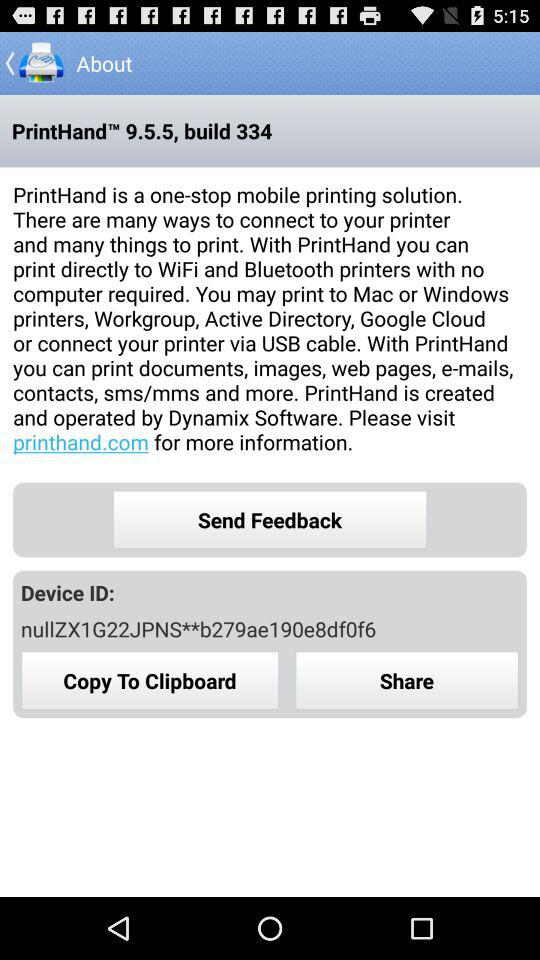Which company created and operates "PrintHand"? The company "Dynamix Software" created and operates "PrintHand". 